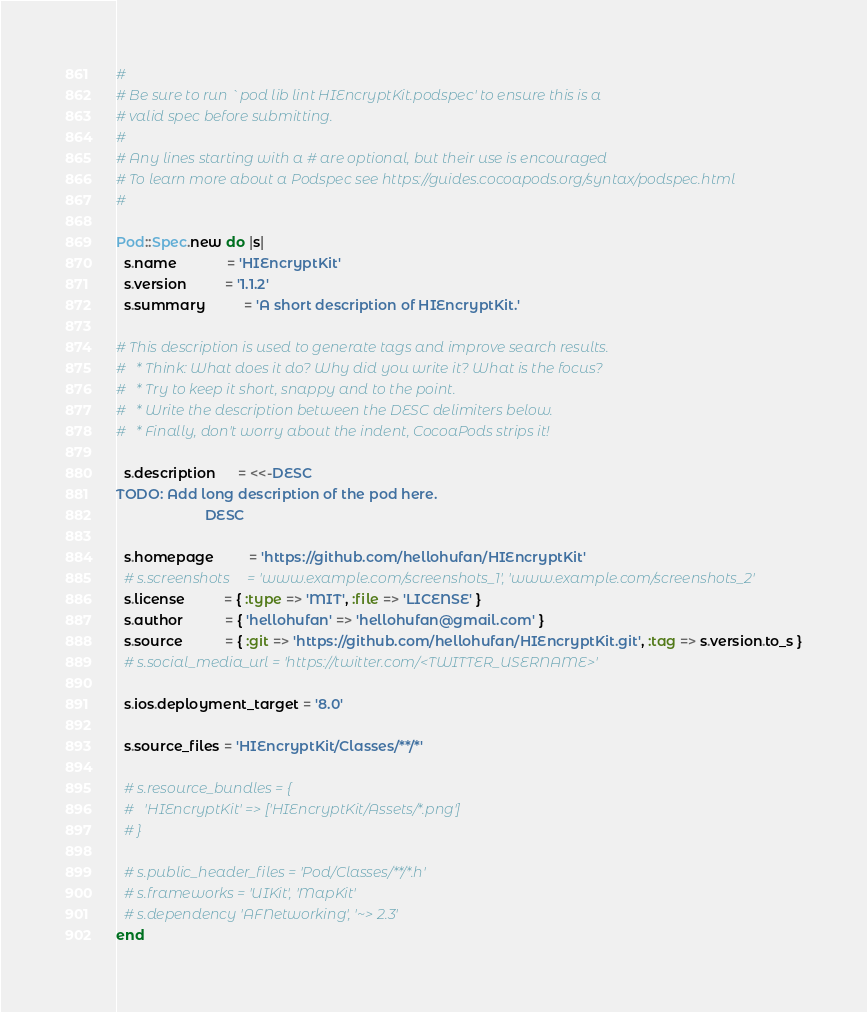Convert code to text. <code><loc_0><loc_0><loc_500><loc_500><_Ruby_>#
# Be sure to run `pod lib lint HIEncryptKit.podspec' to ensure this is a
# valid spec before submitting.
#
# Any lines starting with a # are optional, but their use is encouraged
# To learn more about a Podspec see https://guides.cocoapods.org/syntax/podspec.html
#

Pod::Spec.new do |s|
  s.name             = 'HIEncryptKit'
  s.version          = '1.1.2'
  s.summary          = 'A short description of HIEncryptKit.'

# This description is used to generate tags and improve search results.
#   * Think: What does it do? Why did you write it? What is the focus?
#   * Try to keep it short, snappy and to the point.
#   * Write the description between the DESC delimiters below.
#   * Finally, don't worry about the indent, CocoaPods strips it!

  s.description      = <<-DESC
TODO: Add long description of the pod here.
                       DESC

  s.homepage         = 'https://github.com/hellohufan/HIEncryptKit'
  # s.screenshots     = 'www.example.com/screenshots_1', 'www.example.com/screenshots_2'
  s.license          = { :type => 'MIT', :file => 'LICENSE' }
  s.author           = { 'hellohufan' => 'hellohufan@gmail.com' }
  s.source           = { :git => 'https://github.com/hellohufan/HIEncryptKit.git', :tag => s.version.to_s }
  # s.social_media_url = 'https://twitter.com/<TWITTER_USERNAME>'

  s.ios.deployment_target = '8.0'

  s.source_files = 'HIEncryptKit/Classes/**/*'
  
  # s.resource_bundles = {
  #   'HIEncryptKit' => ['HIEncryptKit/Assets/*.png']
  # }

  # s.public_header_files = 'Pod/Classes/**/*.h'
  # s.frameworks = 'UIKit', 'MapKit'
  # s.dependency 'AFNetworking', '~> 2.3'
end
</code> 